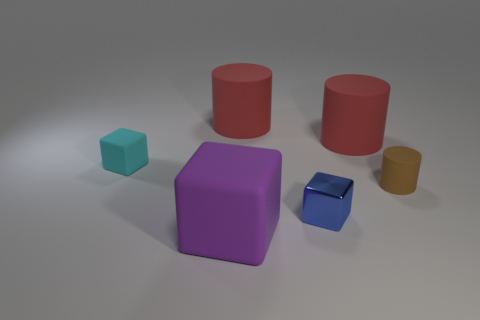Add 3 big red rubber cylinders. How many objects exist? 9 Subtract all big matte cylinders. How many cylinders are left? 1 Subtract all cyan cubes. How many cubes are left? 2 Subtract all blue cylinders. Subtract all blue blocks. How many cylinders are left? 3 Subtract all gray cylinders. How many cyan blocks are left? 1 Subtract all brown spheres. Subtract all small cyan rubber things. How many objects are left? 5 Add 5 big purple matte blocks. How many big purple matte blocks are left? 6 Add 4 tiny brown things. How many tiny brown things exist? 5 Subtract 0 blue cylinders. How many objects are left? 6 Subtract 1 blocks. How many blocks are left? 2 